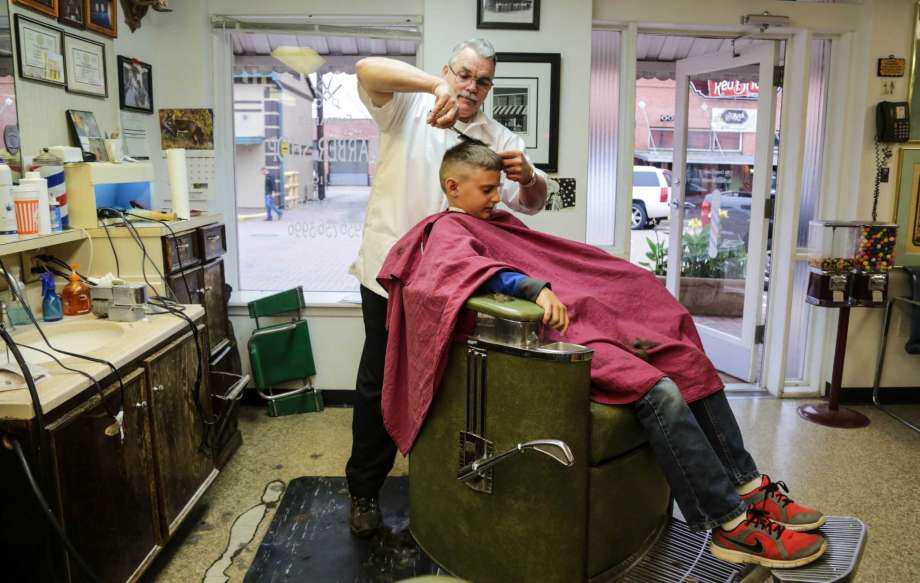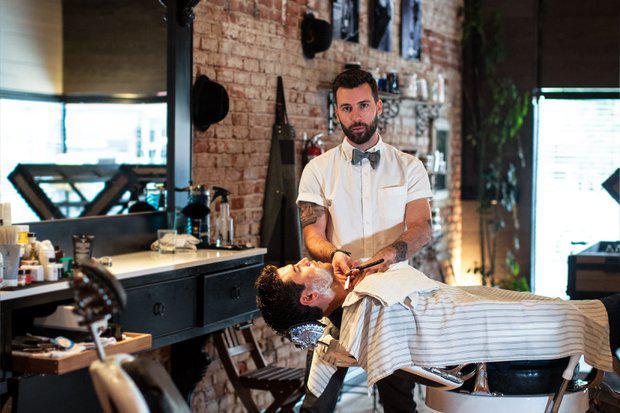The first image is the image on the left, the second image is the image on the right. Given the left and right images, does the statement "There are no more than two people in total in the two shops." hold true? Answer yes or no. No. The first image is the image on the left, the second image is the image on the right. Assess this claim about the two images: "There are people in one image but not in the other image.". Correct or not? Answer yes or no. No. 